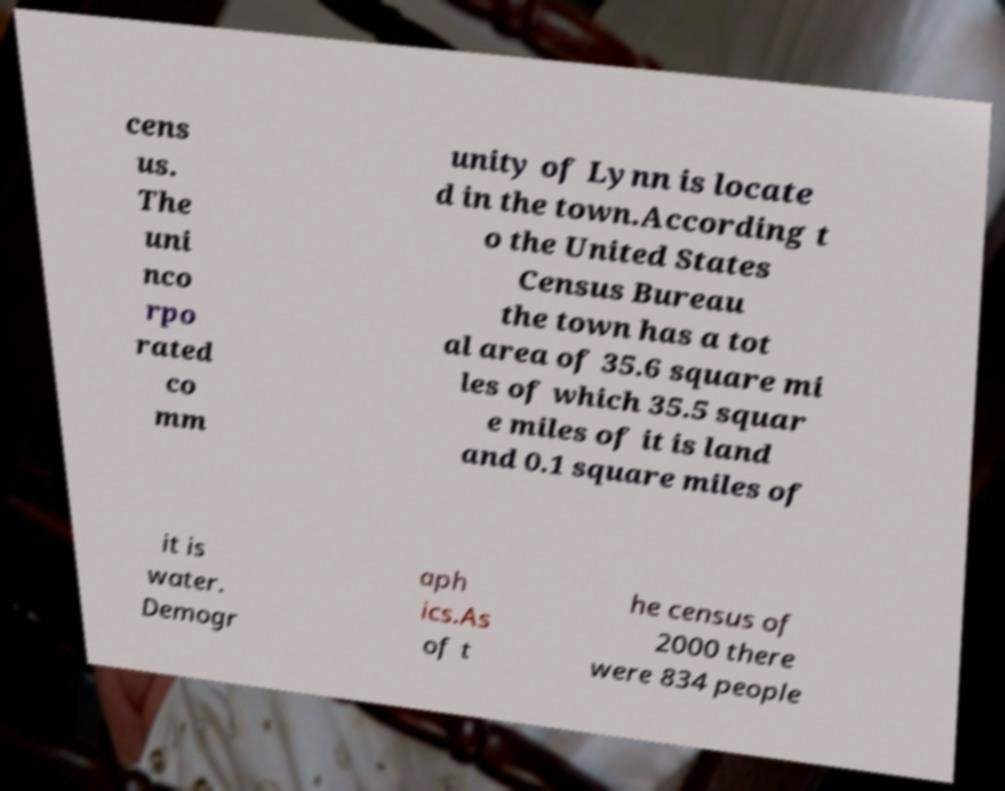Could you assist in decoding the text presented in this image and type it out clearly? cens us. The uni nco rpo rated co mm unity of Lynn is locate d in the town.According t o the United States Census Bureau the town has a tot al area of 35.6 square mi les of which 35.5 squar e miles of it is land and 0.1 square miles of it is water. Demogr aph ics.As of t he census of 2000 there were 834 people 